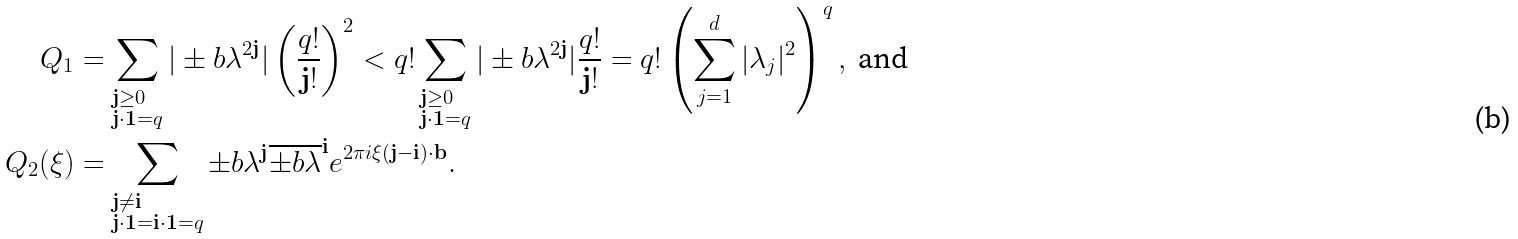<formula> <loc_0><loc_0><loc_500><loc_500>Q _ { 1 } & = \sum _ { \begin{subarray} { c } \mathbf j \geq 0 \\ \mathbf j \cdot \mathbf 1 = q \end{subarray} } | \pm b { \lambda } ^ { 2 \mathbf j } | \left ( \frac { q ! } { \mathbf j ! } \right ) ^ { 2 } < q ! \sum _ { \begin{subarray} { c } \mathbf j \geq 0 \\ \mathbf j \cdot \mathbf 1 = q \end{subarray} } | \pm b { \lambda } ^ { 2 \mathbf j } | \frac { q ! } { \mathbf j ! } = q ! \left ( \sum _ { j = 1 } ^ { d } | \lambda _ { j } | ^ { 2 } \right ) ^ { q } , \text { and } \\ Q _ { 2 } ( \xi ) & = \sum _ { \begin{subarray} { c } \mathbf j \ne \mathbf i \\ \mathbf j \cdot \mathbf 1 = \mathbf i \cdot \mathbf 1 = q \end{subarray} } \pm b { \lambda } ^ { \mathbf j } \overline { \pm b { \lambda } } ^ { \mathbf i } e ^ { 2 \pi i \xi ( \mathbf j - \mathbf i ) \cdot \mathbf b } .</formula> 